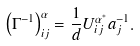<formula> <loc_0><loc_0><loc_500><loc_500>\left ( \Gamma ^ { - 1 } \right ) ^ { \alpha } _ { i j } = \frac { 1 } { d } U ^ { \alpha ^ { * } } _ { i j } a ^ { - 1 } _ { j } .</formula> 